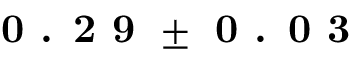<formula> <loc_0><loc_0><loc_500><loc_500>0 . 2 9 \pm 0 . 0 3</formula> 